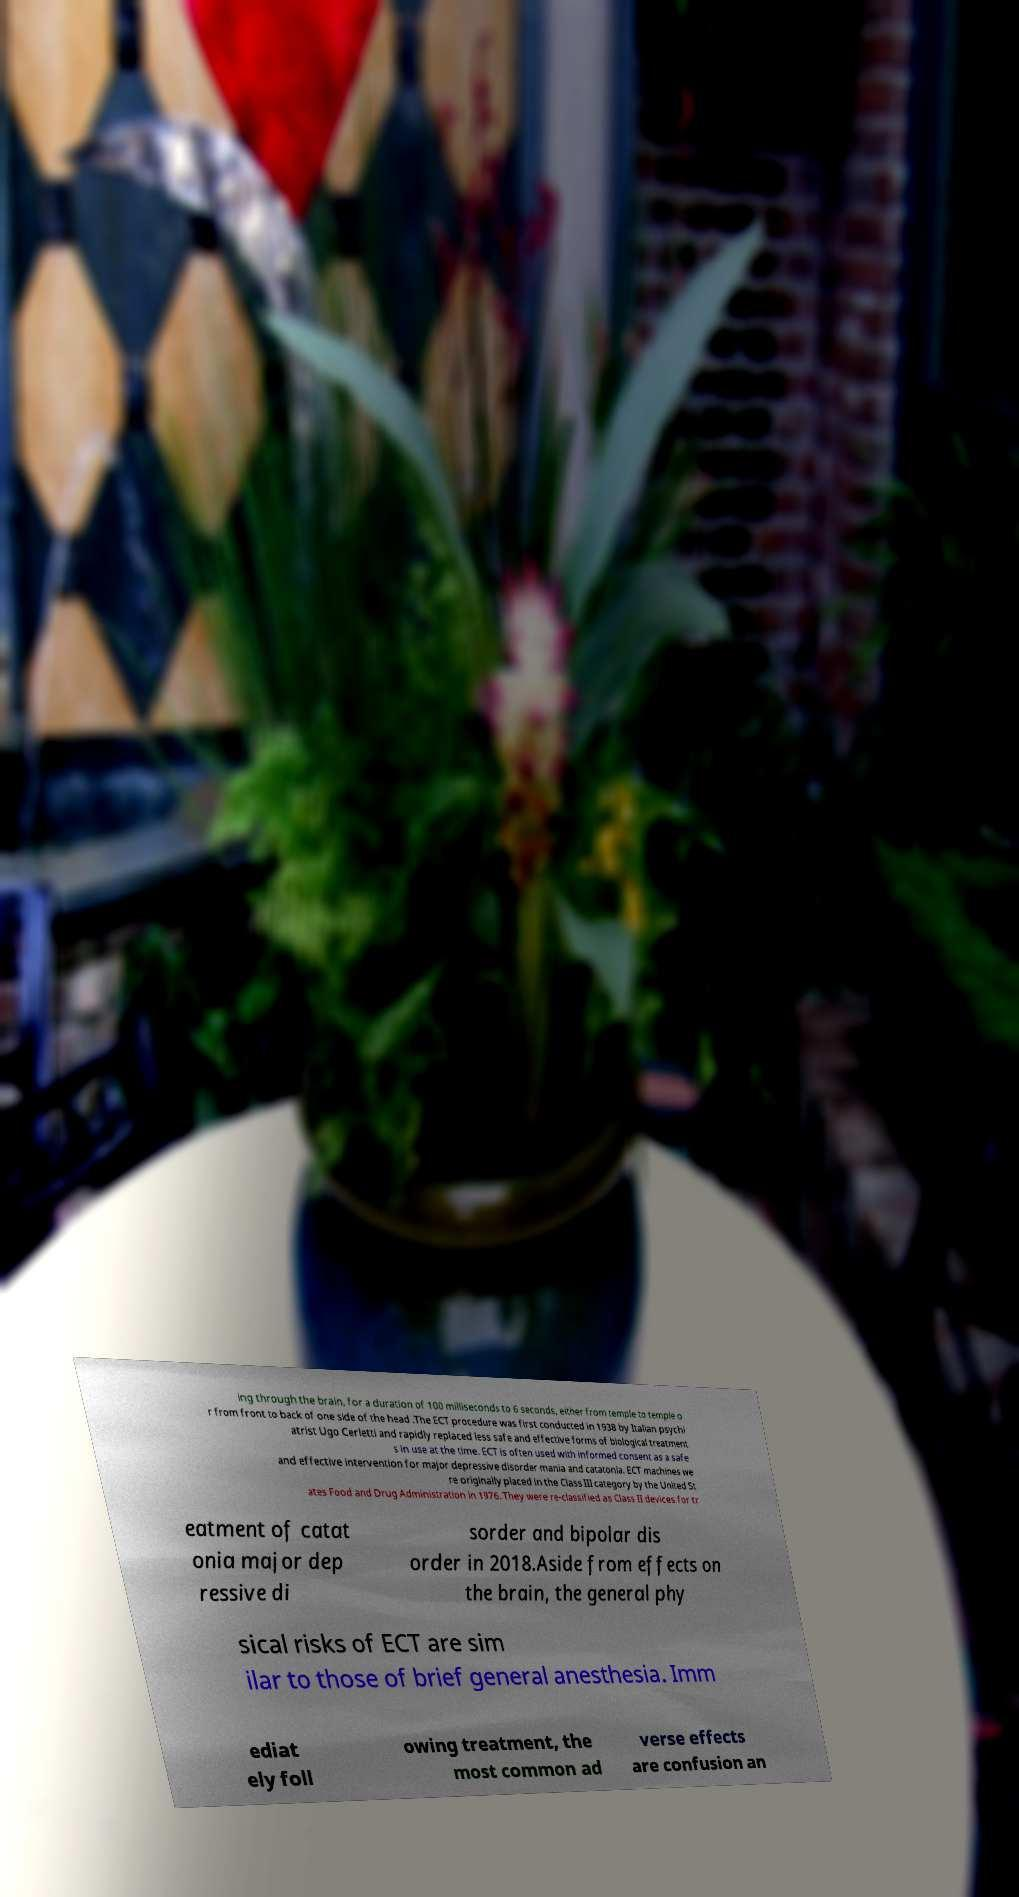Can you accurately transcribe the text from the provided image for me? ing through the brain, for a duration of 100 milliseconds to 6 seconds, either from temple to temple o r from front to back of one side of the head .The ECT procedure was first conducted in 1938 by Italian psychi atrist Ugo Cerletti and rapidly replaced less safe and effective forms of biological treatment s in use at the time. ECT is often used with informed consent as a safe and effective intervention for major depressive disorder mania and catatonia. ECT machines we re originally placed in the Class III category by the United St ates Food and Drug Administration in 1976. They were re-classified as Class II devices for tr eatment of catat onia major dep ressive di sorder and bipolar dis order in 2018.Aside from effects on the brain, the general phy sical risks of ECT are sim ilar to those of brief general anesthesia. Imm ediat ely foll owing treatment, the most common ad verse effects are confusion an 